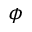Convert formula to latex. <formula><loc_0><loc_0><loc_500><loc_500>\phi</formula> 